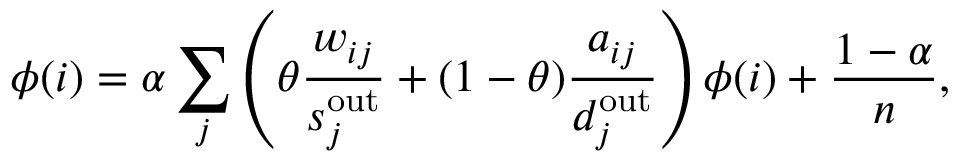<formula> <loc_0><loc_0><loc_500><loc_500>\phi ( i ) = \alpha \sum _ { j } \left ( \theta \frac { w _ { i j } } { s _ { j } ^ { o u t } } + ( 1 - \theta ) \frac { a _ { i j } } { d _ { j } ^ { o u t } } \right ) \phi ( i ) + \frac { 1 - \alpha } { n } ,</formula> 